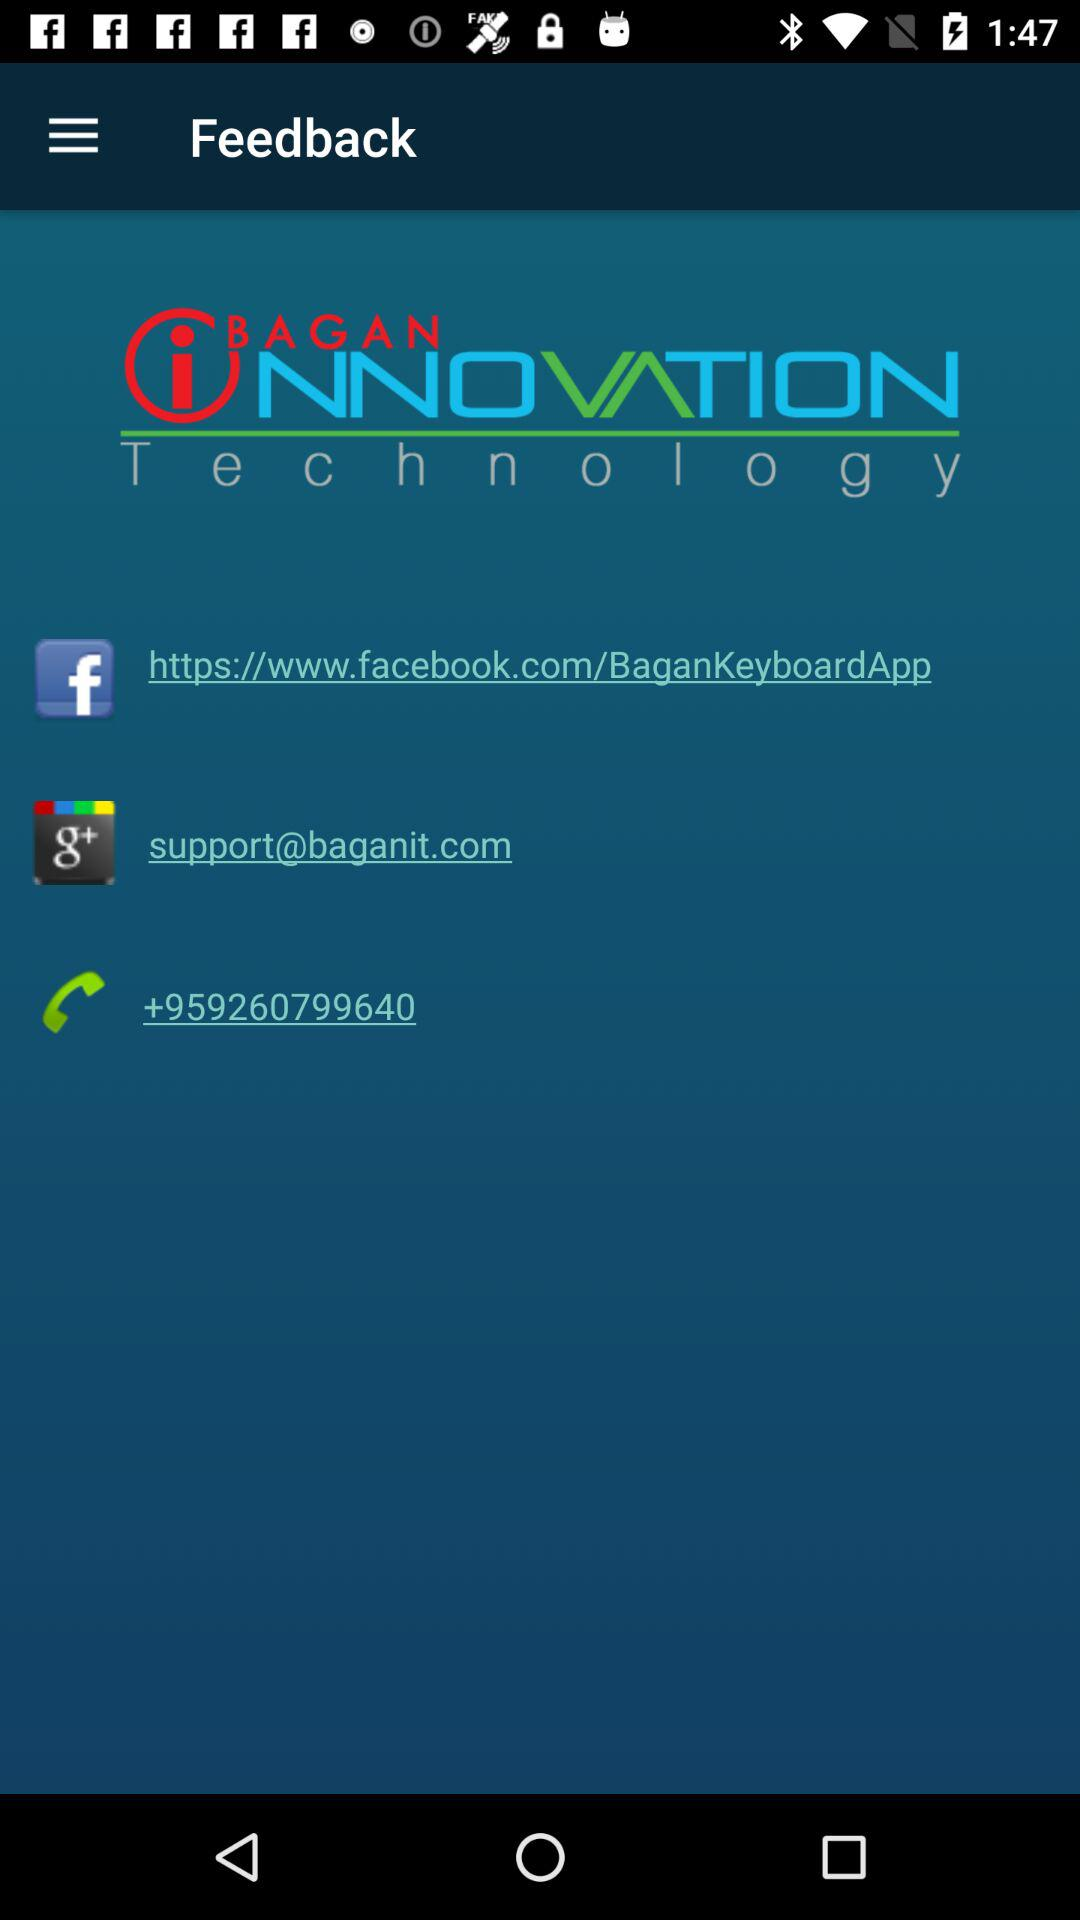What is the application name? The name of the application is "Bagan Innovation Technology". 